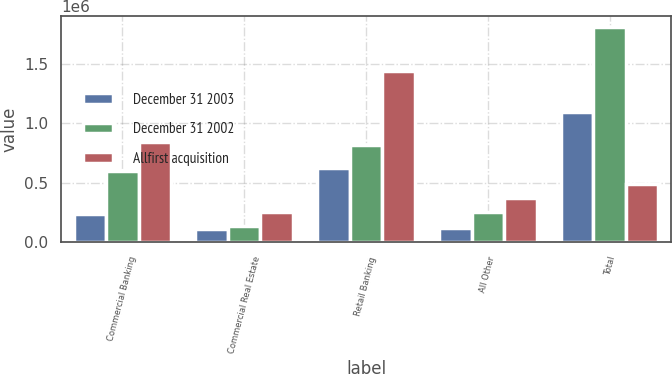<chart> <loc_0><loc_0><loc_500><loc_500><stacked_bar_chart><ecel><fcel>Commercial Banking<fcel>Commercial Real Estate<fcel>Retail Banking<fcel>All Other<fcel>Total<nl><fcel>December 31 2003<fcel>236012<fcel>114883<fcel>627564<fcel>119094<fcel>1.09755e+06<nl><fcel>December 31 2002<fcel>602153<fcel>140283<fcel>813361<fcel>250731<fcel>1.80653e+06<nl><fcel>Allfirst acquisition<fcel>838165<fcel>255166<fcel>1.44092e+06<fcel>369825<fcel>485989<nl></chart> 